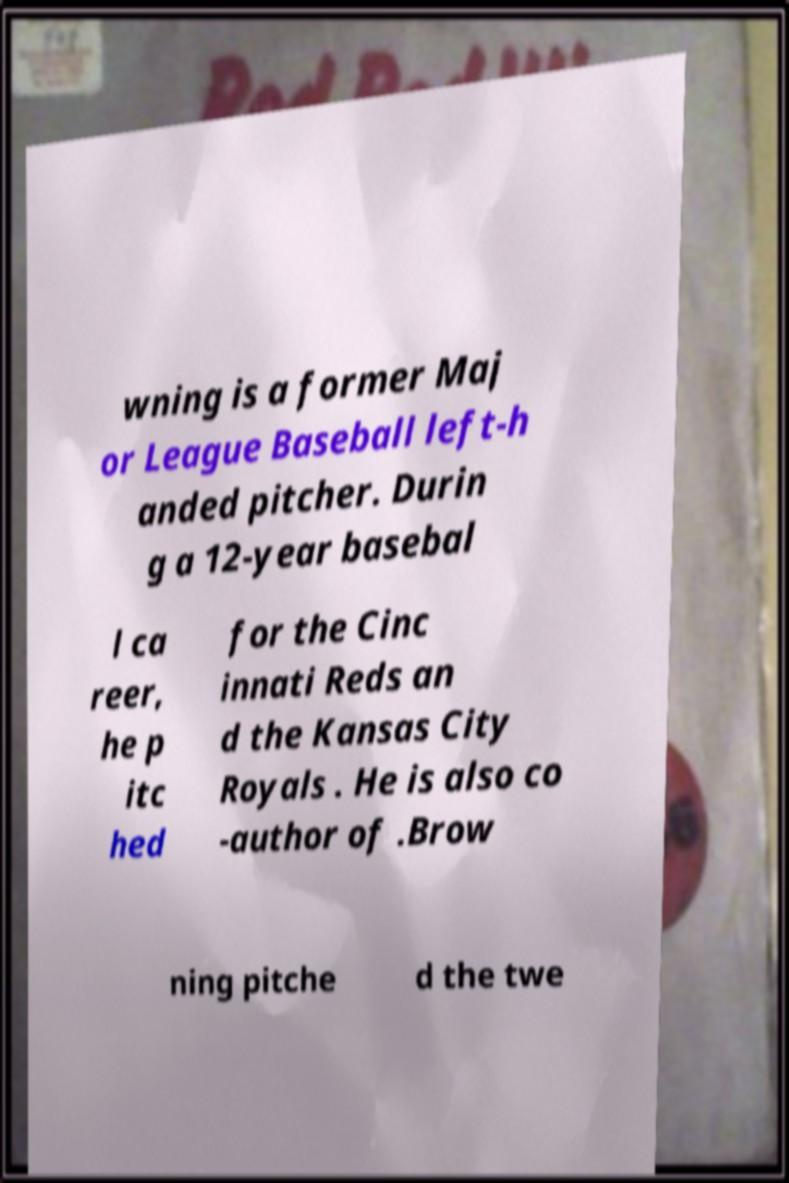What messages or text are displayed in this image? I need them in a readable, typed format. wning is a former Maj or League Baseball left-h anded pitcher. Durin g a 12-year basebal l ca reer, he p itc hed for the Cinc innati Reds an d the Kansas City Royals . He is also co -author of .Brow ning pitche d the twe 